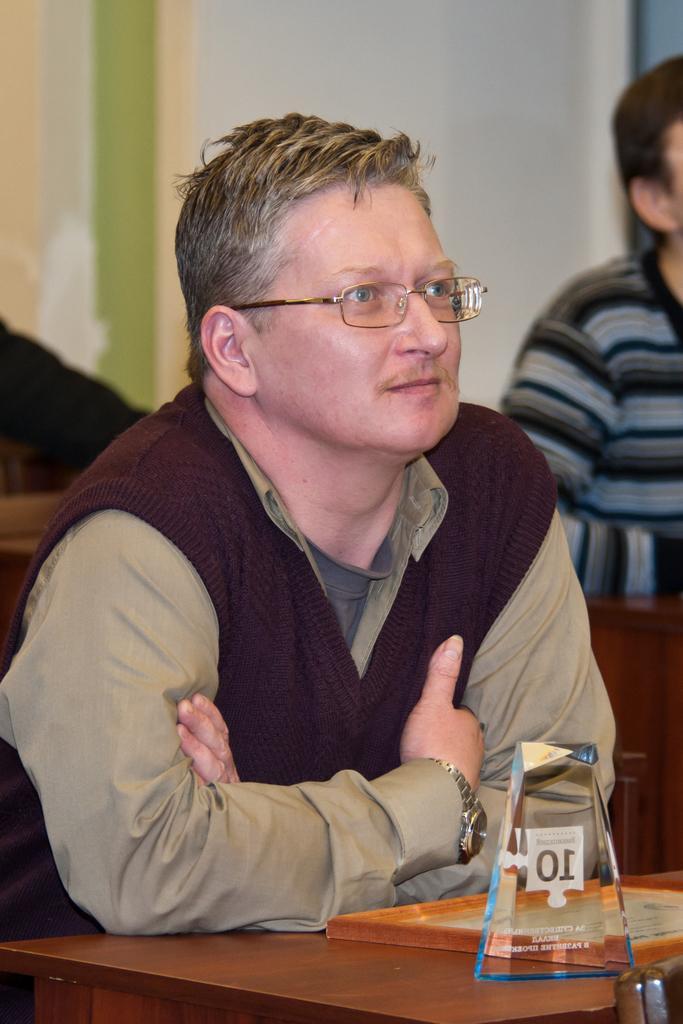In one or two sentences, can you explain what this image depicts? In the image there is a man sitting in front of a table and on the table there are two objects, behind the man there is another person and the background is blurry. 